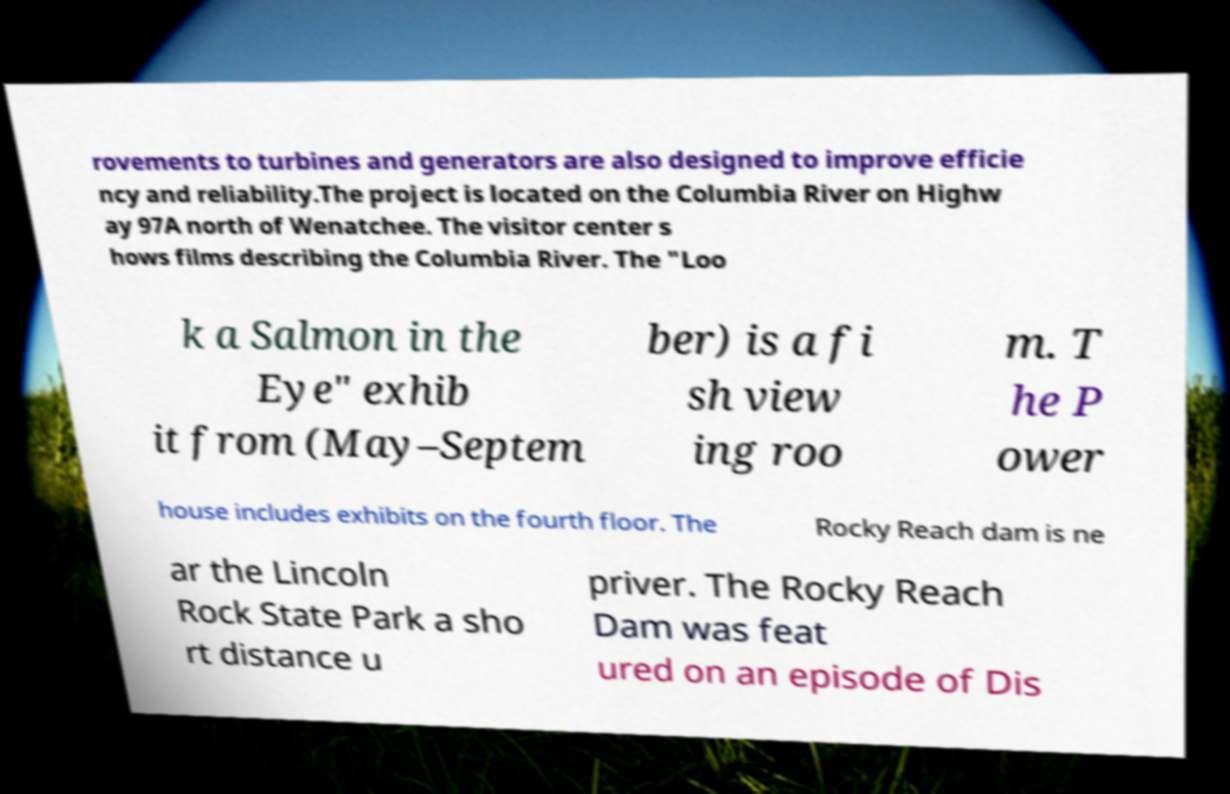Can you read and provide the text displayed in the image?This photo seems to have some interesting text. Can you extract and type it out for me? rovements to turbines and generators are also designed to improve efficie ncy and reliability.The project is located on the Columbia River on Highw ay 97A north of Wenatchee. The visitor center s hows films describing the Columbia River. The "Loo k a Salmon in the Eye" exhib it from (May–Septem ber) is a fi sh view ing roo m. T he P ower house includes exhibits on the fourth floor. The Rocky Reach dam is ne ar the Lincoln Rock State Park a sho rt distance u priver. The Rocky Reach Dam was feat ured on an episode of Dis 